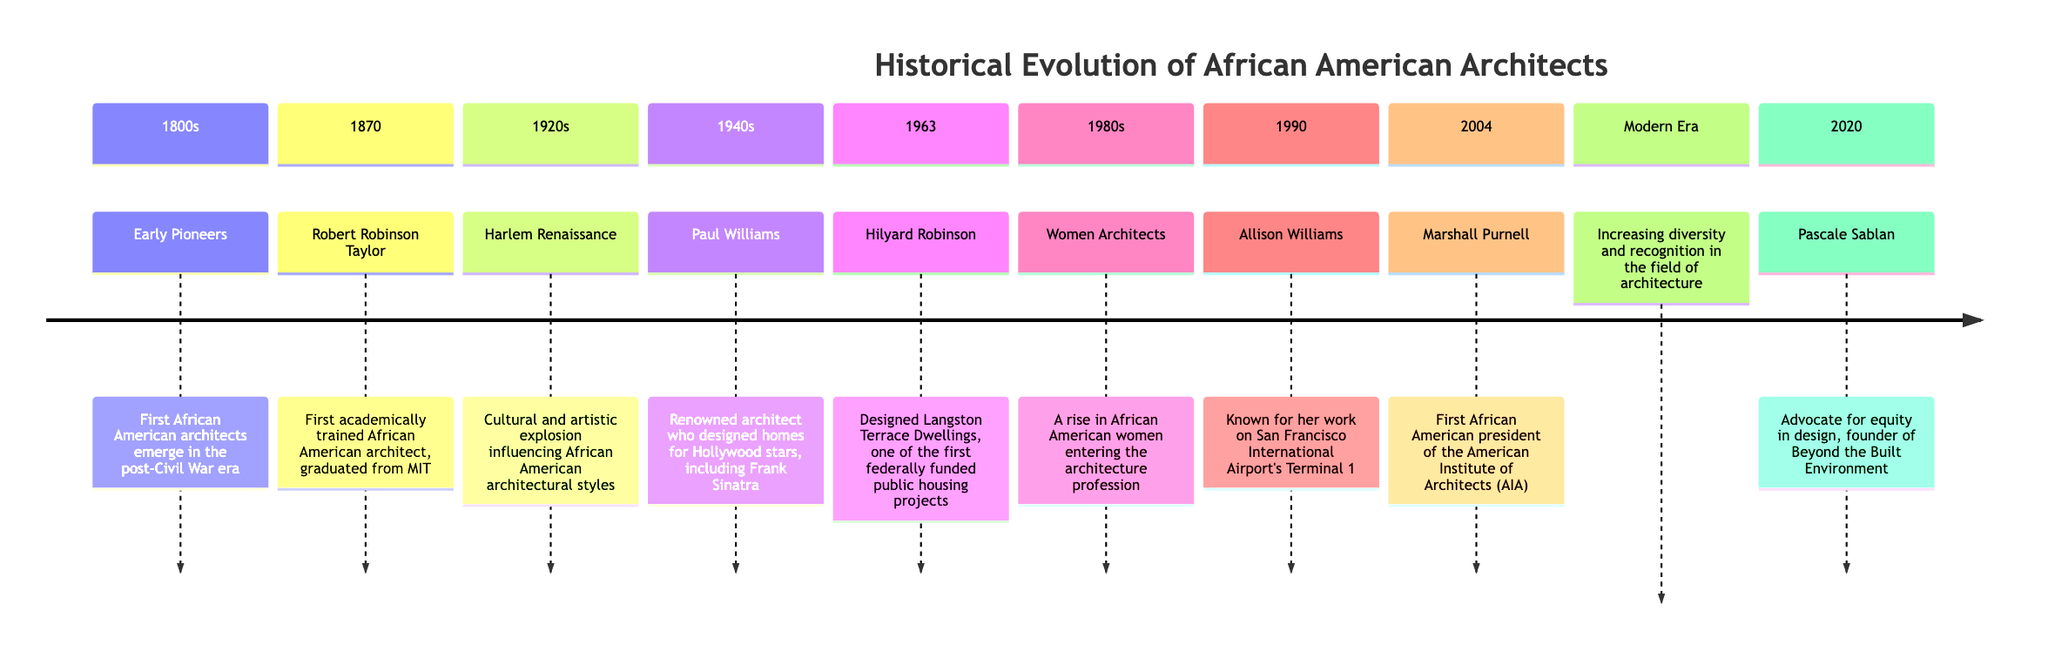What decade did the Harlem Renaissance occur? The diagram specifies the Harlem Renaissance in the 1920s section. Since the question is asking for the specific decade during which this cultural influence happened, we identify the number 1920s directly from that section.
Answer: 1920s Who was the first academically trained African American architect? The diagram names Robert Robinson Taylor in the 1870 section as the first academically trained African American architect. Therefore, the answer is directly derived from that part of the timeline.
Answer: Robert Robinson Taylor In which year did Hilyard Robinson design the Langston Terrace Dwellings? The section for Hilyard Robinson states that he designed the Langston Terrace Dwellings in 1963. This date is clearly presented in the diagram, providing the direct answer to the question.
Answer: 1963 How many sections are dedicated to architects and their contributions after 1980? The diagram includes three sections after 1980: "Women Architects" in the 1980s, "Allison Williams" in 1990, and "Marshall Purnell" in 2004. Therefore, by counting these sections, we determine the total number.
Answer: 3 Which architect is known for designing homes for Hollywood stars? The section referring to Paul Williams in the 1940s outlines his renown for designing homes for Hollywood stars, including a notable mention of Frank Sinatra. This specifies the architect in the context required.
Answer: Paul Williams What movement influenced African American architectural styles in the 1920s? The flow of the diagram points to the Harlem Renaissance in the 1920s section as the cultural and artistic movement that greatly influenced African American architectural styles.
Answer: Harlem Renaissance Who is the founder of Beyond the Built Environment? In the Modern Era section, Pascale Sablan is mentioned as the advocate for equity in design and the founder of Beyond the Built Environment. This directly addresses the question regarding the founder.
Answer: Pascale Sablan What significant event in architecture occurred in 2004? The diagram states that in 2004, Marshall Purnell became the first African American president of the American Institute of Architects (AIA). This identifies the key event in that specific year.
Answer: Marshall Purnell 